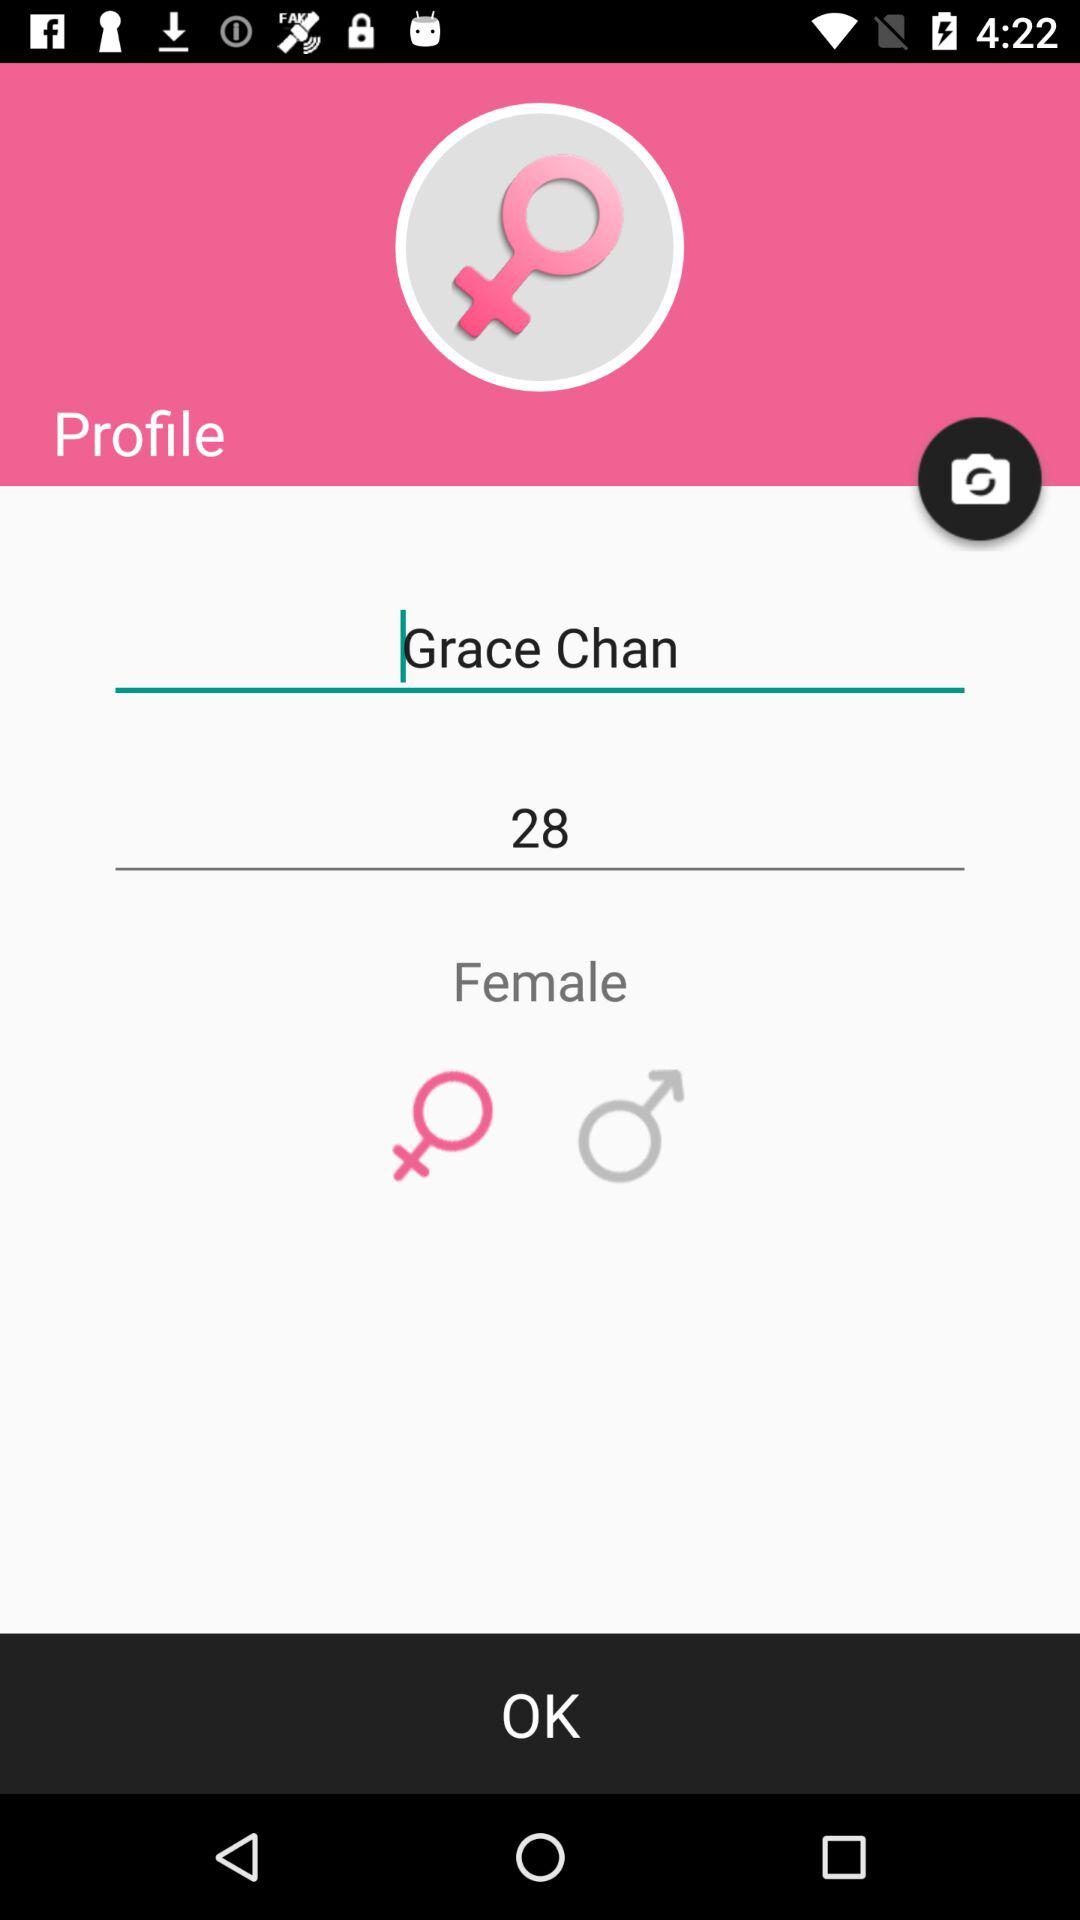What is the age of the user? The age of the user is 28 years. 